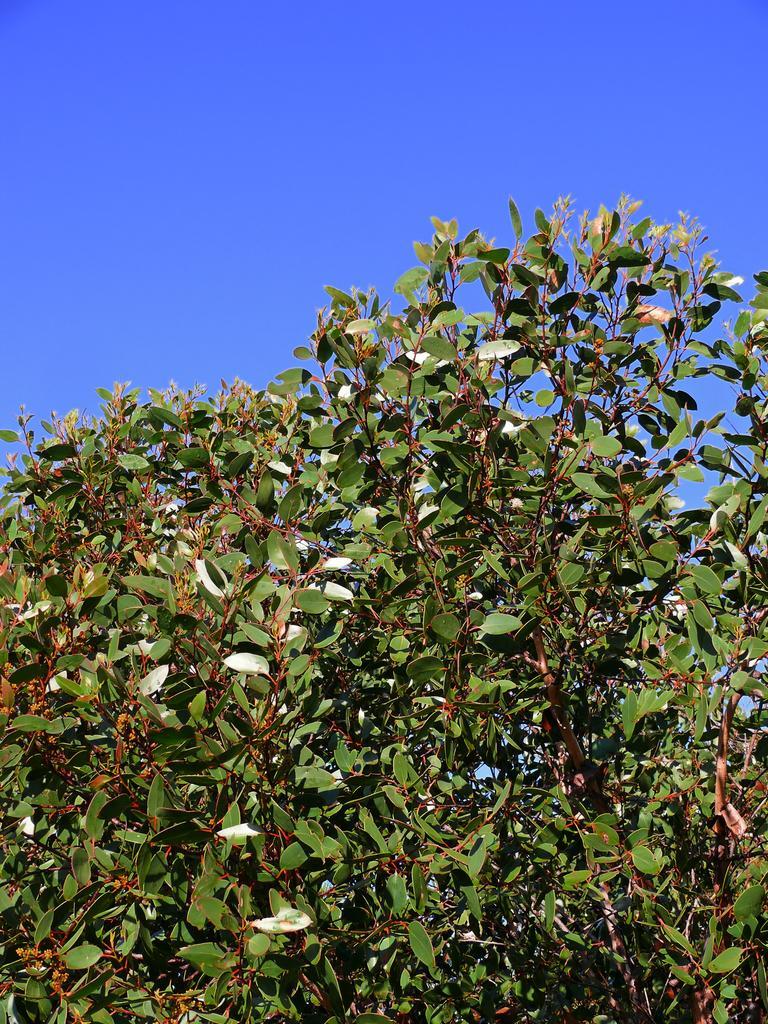Please provide a concise description of this image. In this image, we can see plants that are green in color. We can also see the sky. 